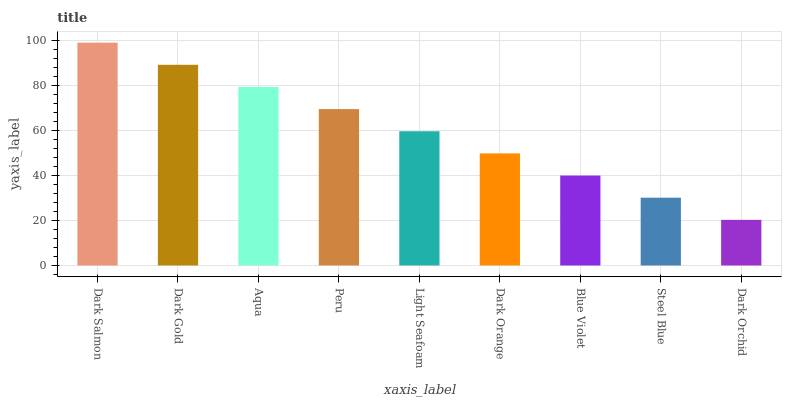Is Dark Orchid the minimum?
Answer yes or no. Yes. Is Dark Salmon the maximum?
Answer yes or no. Yes. Is Dark Gold the minimum?
Answer yes or no. No. Is Dark Gold the maximum?
Answer yes or no. No. Is Dark Salmon greater than Dark Gold?
Answer yes or no. Yes. Is Dark Gold less than Dark Salmon?
Answer yes or no. Yes. Is Dark Gold greater than Dark Salmon?
Answer yes or no. No. Is Dark Salmon less than Dark Gold?
Answer yes or no. No. Is Light Seafoam the high median?
Answer yes or no. Yes. Is Light Seafoam the low median?
Answer yes or no. Yes. Is Dark Gold the high median?
Answer yes or no. No. Is Dark Salmon the low median?
Answer yes or no. No. 